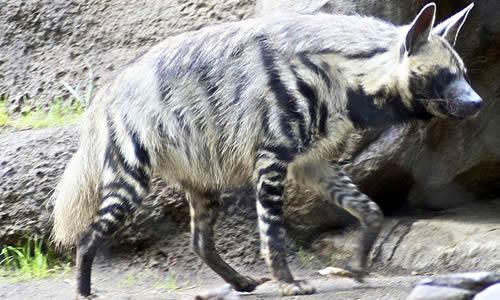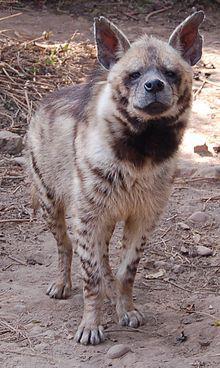The first image is the image on the left, the second image is the image on the right. For the images shown, is this caption "The animal in one of the images has its body turned toward the camera." true? Answer yes or no. Yes. 